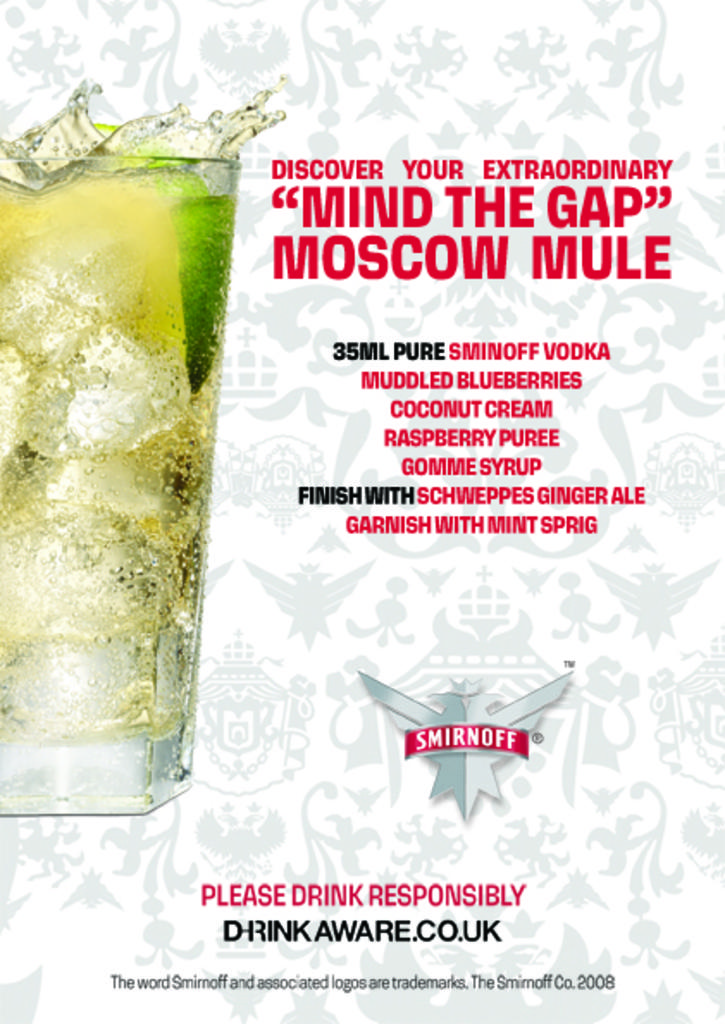What is contained in the glass that is visible in the image? There is a glass with ice and drink in the image. What else can be seen in the image besides the glass? There is text and a logo in the image. How does the train beginner learn to operate the boot in the image? There is no train, beginner, or boot present in the image. 